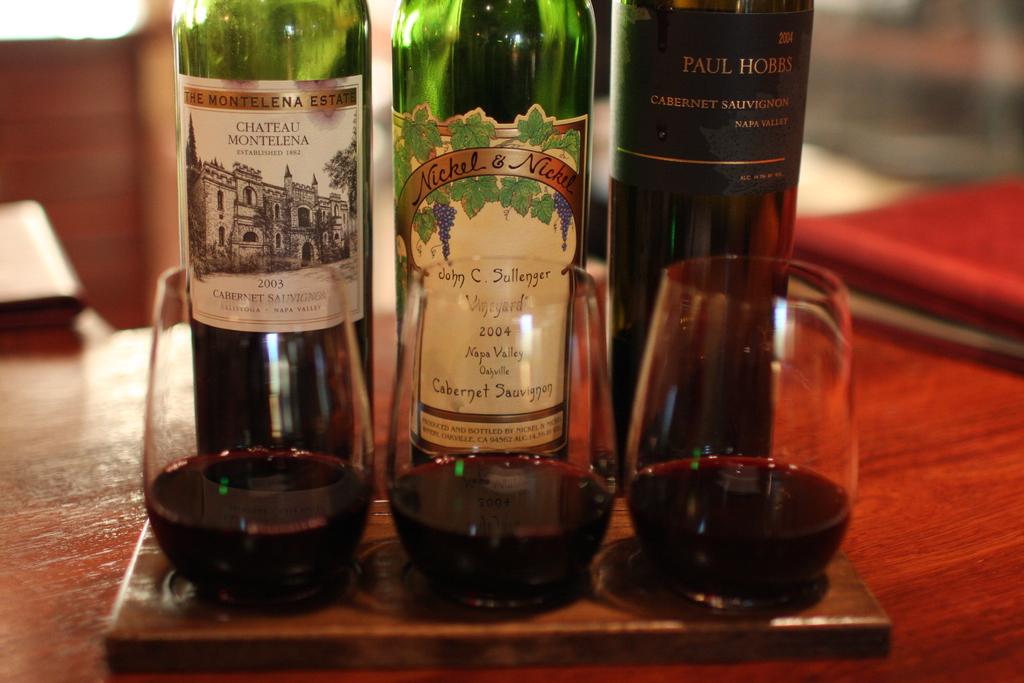Which wine is on the right?
Make the answer very short. Paul hobbs. Which wine is on the left?
Give a very brief answer. Chateau montelena. 